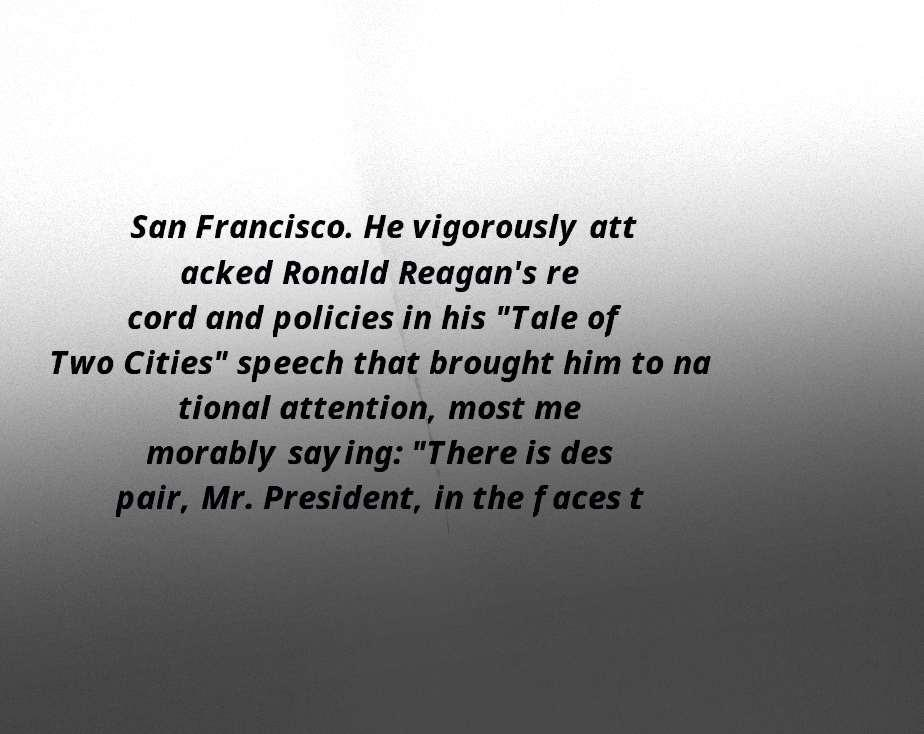I need the written content from this picture converted into text. Can you do that? San Francisco. He vigorously att acked Ronald Reagan's re cord and policies in his "Tale of Two Cities" speech that brought him to na tional attention, most me morably saying: "There is des pair, Mr. President, in the faces t 